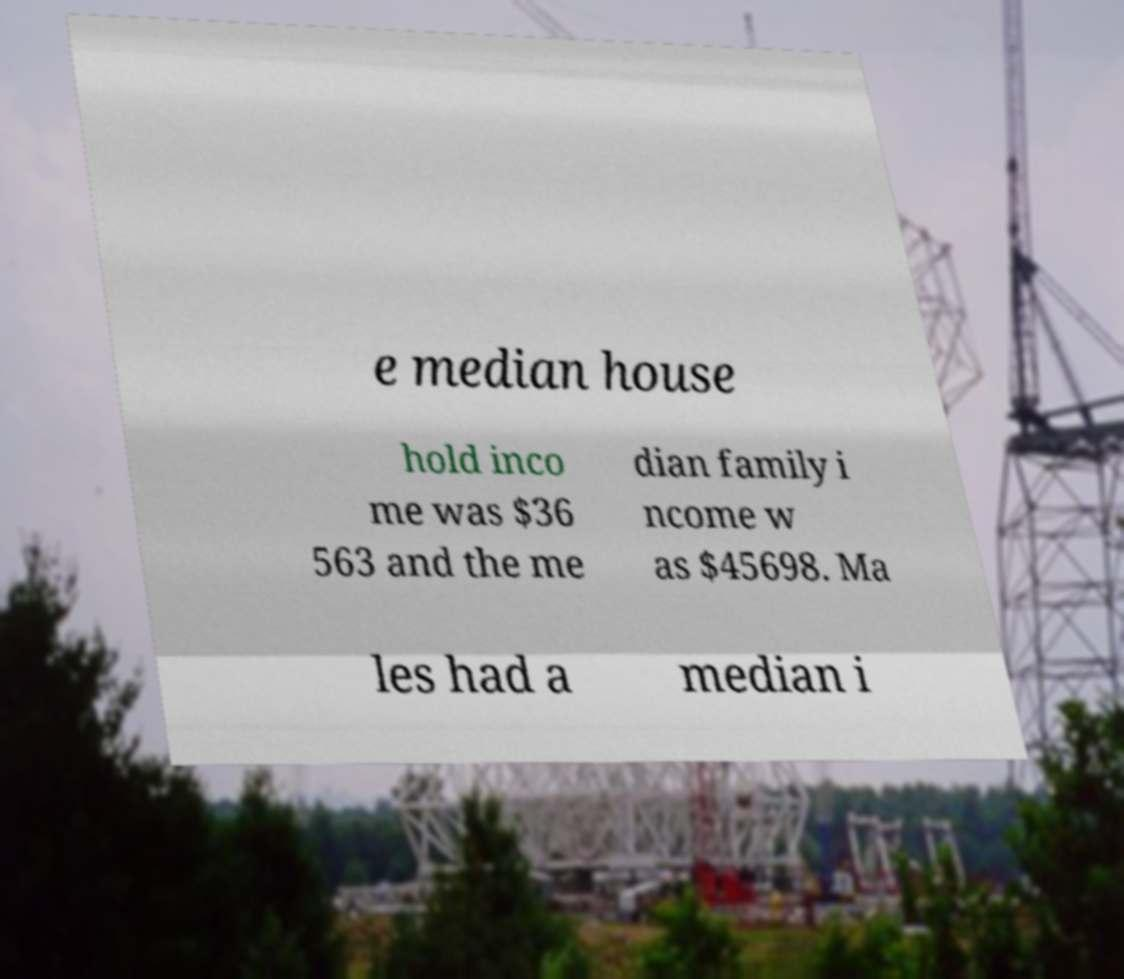Could you assist in decoding the text presented in this image and type it out clearly? e median house hold inco me was $36 563 and the me dian family i ncome w as $45698. Ma les had a median i 